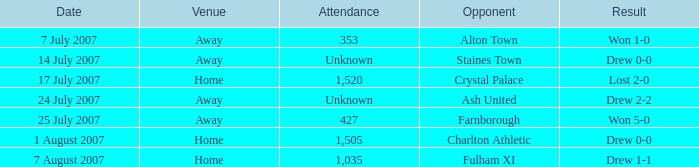Name the venue for staines town Away. 